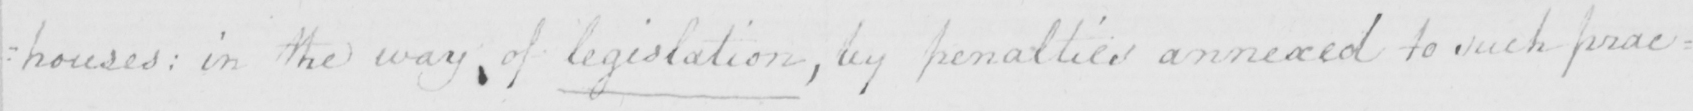Transcribe the text shown in this historical manuscript line. : houses :  in the way of legislation , by penalties annexed to such prac= 